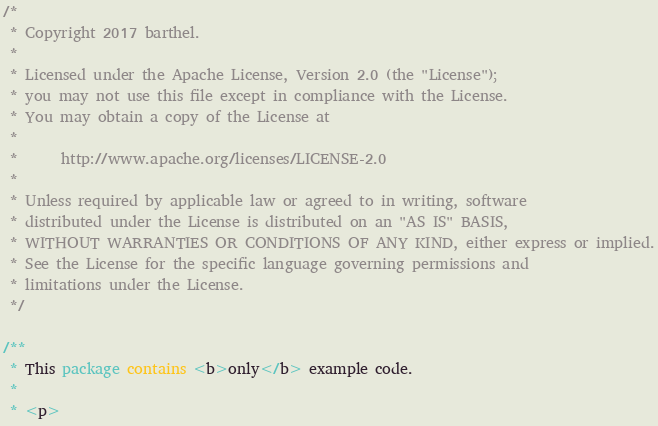<code> <loc_0><loc_0><loc_500><loc_500><_Java_>/*
 * Copyright 2017 barthel.
 *
 * Licensed under the Apache License, Version 2.0 (the "License");
 * you may not use this file except in compliance with the License.
 * You may obtain a copy of the License at
 *
 *      http://www.apache.org/licenses/LICENSE-2.0
 *
 * Unless required by applicable law or agreed to in writing, software
 * distributed under the License is distributed on an "AS IS" BASIS,
 * WITHOUT WARRANTIES OR CONDITIONS OF ANY KIND, either express or implied.
 * See the License for the specific language governing permissions and
 * limitations under the License.
 */

/**
 * This package contains <b>only</b> example code.
 *
 * <p></code> 